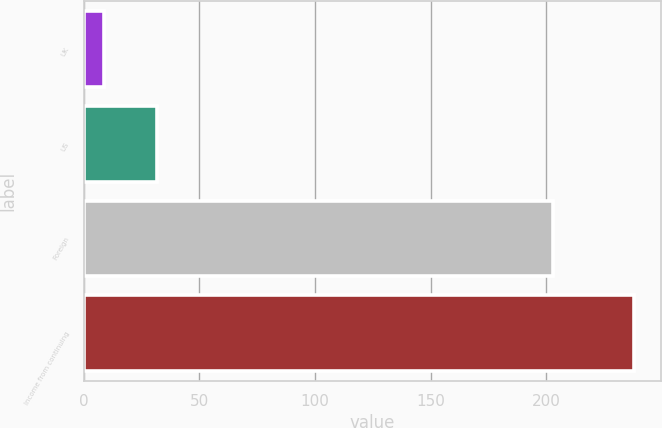Convert chart to OTSL. <chart><loc_0><loc_0><loc_500><loc_500><bar_chart><fcel>UK<fcel>US<fcel>Foreign<fcel>Income from continuing<nl><fcel>8.9<fcel>31.79<fcel>202.8<fcel>237.8<nl></chart> 